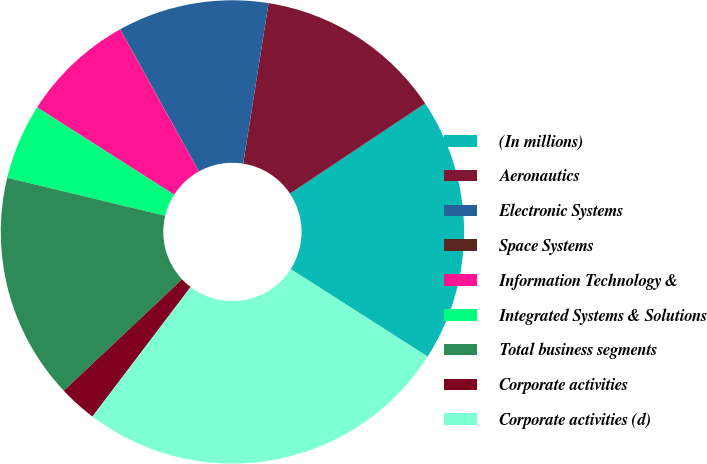Convert chart. <chart><loc_0><loc_0><loc_500><loc_500><pie_chart><fcel>(In millions)<fcel>Aeronautics<fcel>Electronic Systems<fcel>Space Systems<fcel>Information Technology &<fcel>Integrated Systems & Solutions<fcel>Total business segments<fcel>Corporate activities<fcel>Corporate activities (d)<nl><fcel>18.4%<fcel>13.15%<fcel>10.53%<fcel>0.03%<fcel>7.9%<fcel>5.28%<fcel>15.78%<fcel>2.65%<fcel>26.28%<nl></chart> 